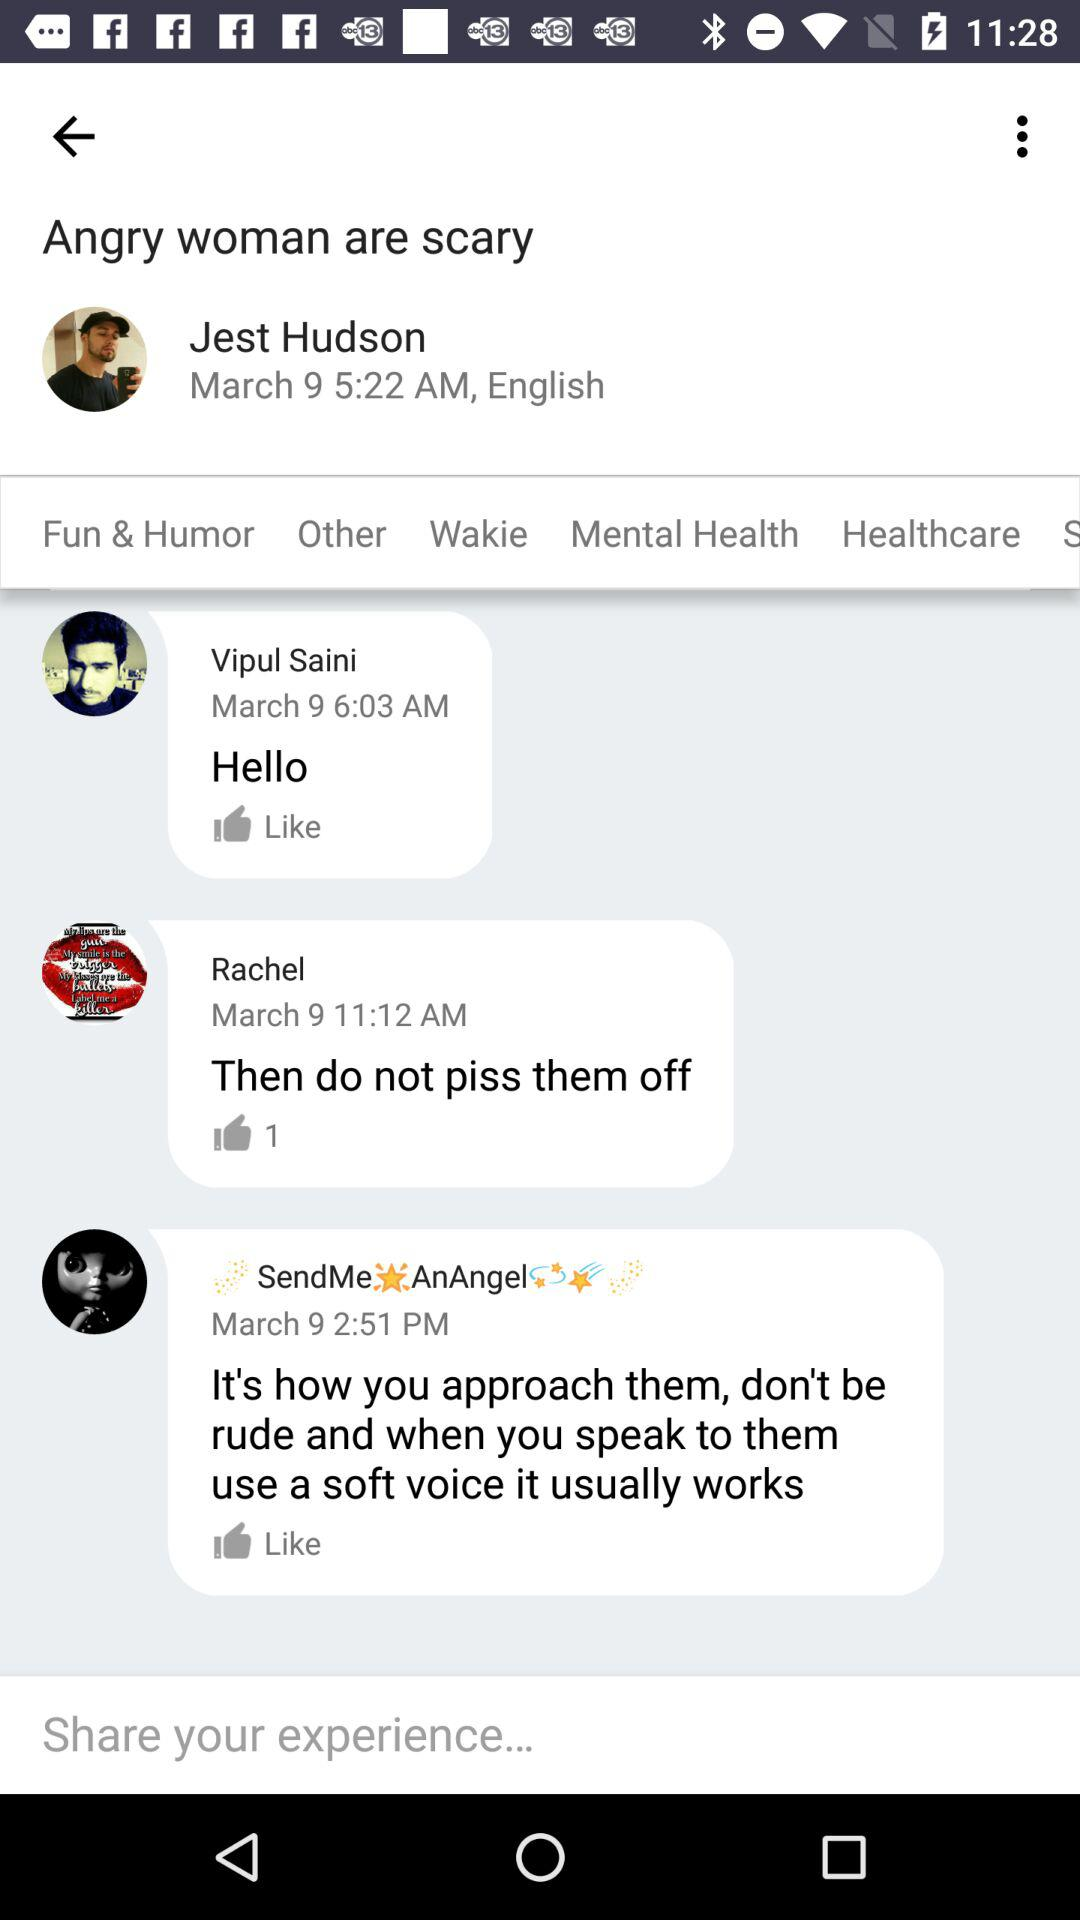How many comments are there on this post?
Answer the question using a single word or phrase. 3 